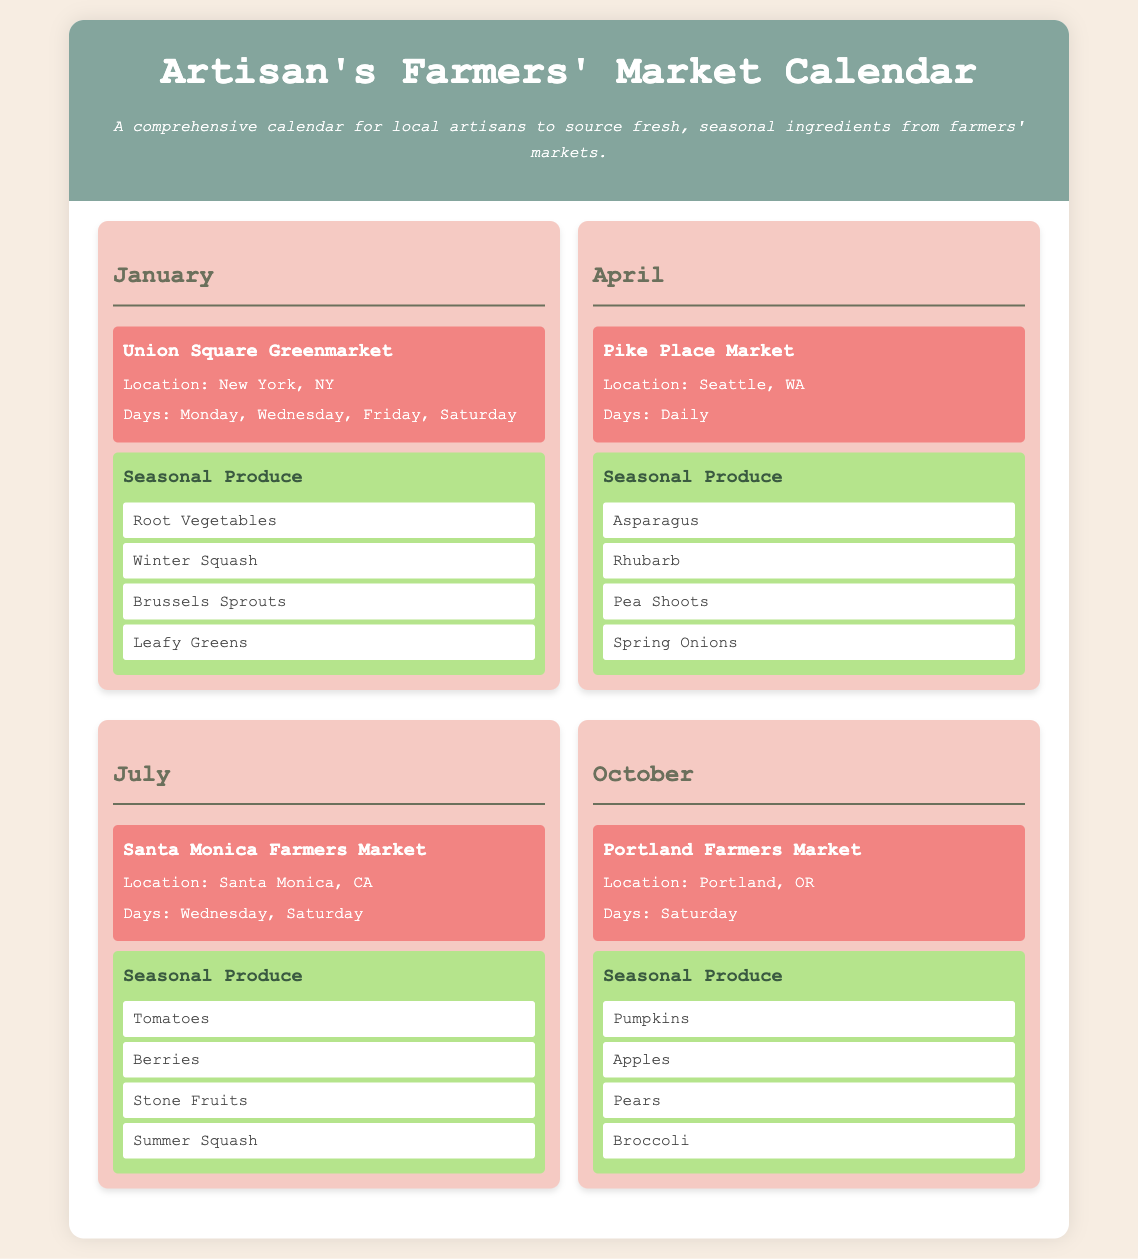what is the location of the Union Square Greenmarket? The location of the Union Square Greenmarket is mentioned in the document as New York, NY.
Answer: New York, NY which market operates daily in April? The document states that Pike Place Market operates daily in April.
Answer: Pike Place Market how many days does the Santa Monica Farmers Market operate? The document indicates that the Santa Monica Farmers Market operates on Wednesdays and Saturdays, totaling two days.
Answer: Two days what seasonal produce is available in October? The document lists the seasonal produce available in October, which includes pumpkins, apples, pears, and broccoli.
Answer: Pumpkins, Apples, Pears, Broccoli in which month can you find rhubarb? The document specifies that rhubarb is available in April.
Answer: April how many seasonal produce items are highlighted for July? The document highlights four seasonal produce items for July: tomatoes, berries, stone fruits, and summer squash.
Answer: Four items which month features Brussels sprouts as seasonal produce? The seasonal produce list in the document for January includes Brussels sprouts.
Answer: January what is the unique aspect of the farmers' market schedule? The unique aspect of the farmers' market schedule is its focus on seasonal produce sourcing for local artisans.
Answer: Seasonal produce sourcing 